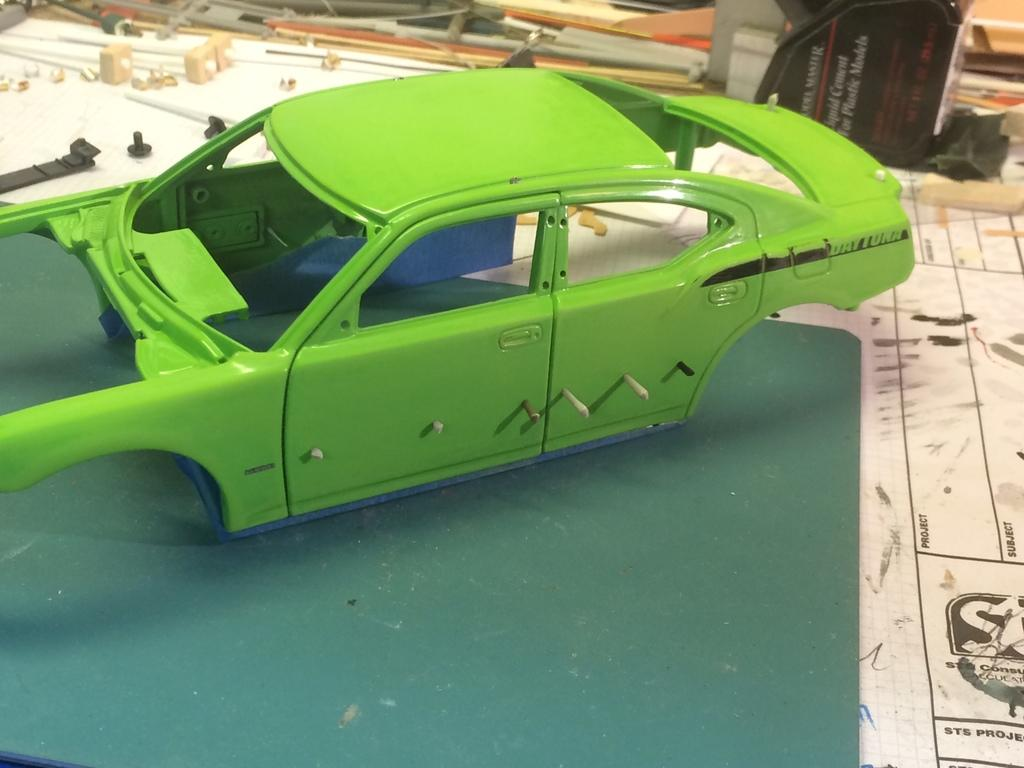What is the main object in the image? There is a toy car in the image. What can be found on the table in the image? There are other objects on the table in the image. What type of mailbox is located near the toy car in the image? There is no mailbox present in the image; it only features a toy car and other objects on the table. 